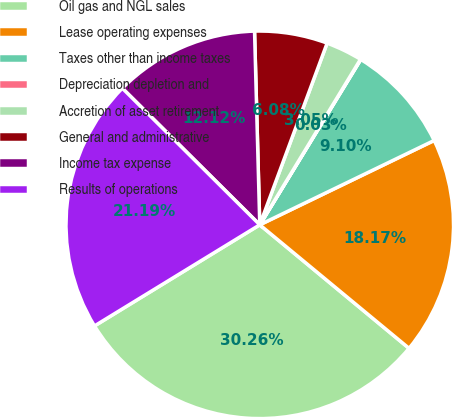Convert chart. <chart><loc_0><loc_0><loc_500><loc_500><pie_chart><fcel>Oil gas and NGL sales<fcel>Lease operating expenses<fcel>Taxes other than income taxes<fcel>Depreciation depletion and<fcel>Accretion of asset retirement<fcel>General and administrative<fcel>Income tax expense<fcel>Results of operations<nl><fcel>30.26%<fcel>18.17%<fcel>9.1%<fcel>0.03%<fcel>3.05%<fcel>6.08%<fcel>12.12%<fcel>21.19%<nl></chart> 